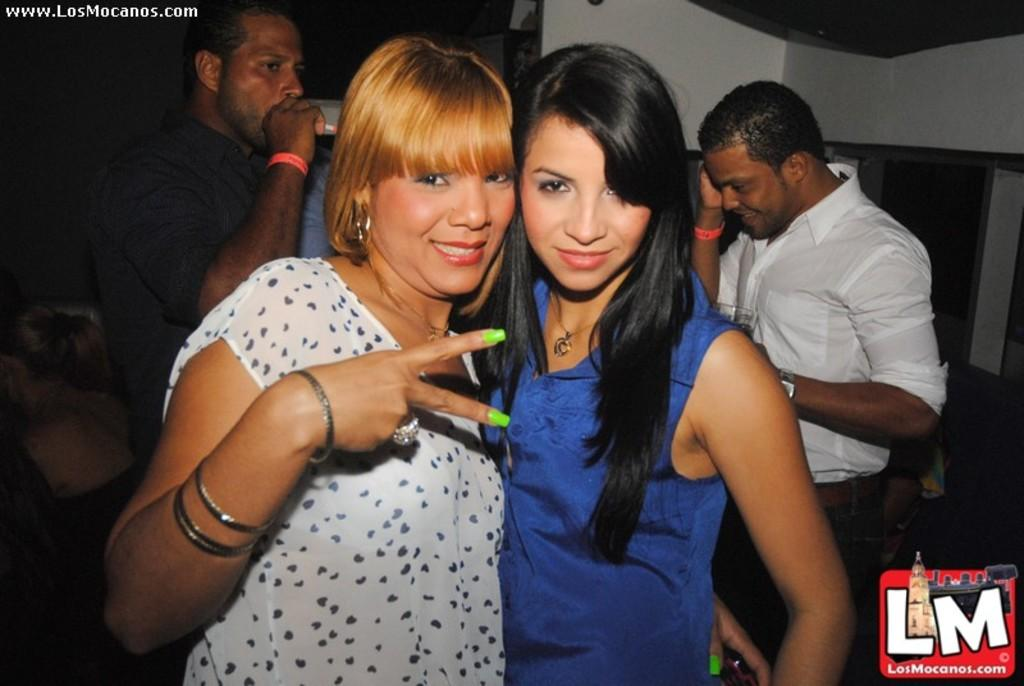How many people are in the image? There are four persons in the image. What else can be seen in the image besides the people? There is a logo and a wall visible in the image. What is the color of the background in the image? The background of the image is dark. What type of suit is the person wearing in the image? There is no person wearing a suit in the image. How many fingers can be seen pointing at the logo in the image? There are no fingers pointing at the logo in the image. 